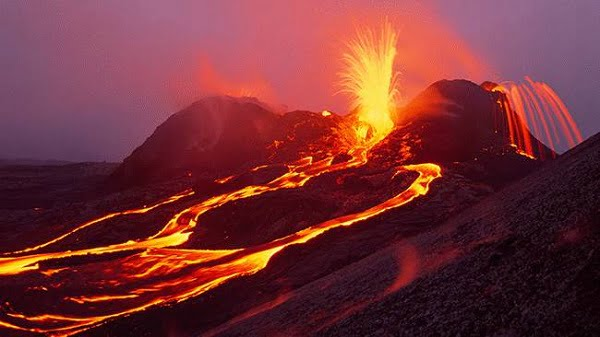Can you elaborate on the elements of the picture provided? The image showcases a captivating and vigorous volcanic eruption, possibly from the Kilauea or Mauna Loa volcanoes that are part of the Hawaii Volcanoes National Park. Streams of incandescent, molten lava illuminate the scene with their fiery glow, flowing sinuously down the mountain slopes. The lava's radiant yellow, orange, and red hues strikingly contrast with the ashy gray sky enveloped in volcanic gas and smoke. Sparse vegetation may be at risk, reflecting the impact such an eruption can have on the local ecosystem. In the distance, the barren and rocky terrain accentuates the raw power of nature's geological forces. Observing such a monumental event from a safe standpoint allows us to appreciate the scale and energy of Earth's internal heat being violently released. 